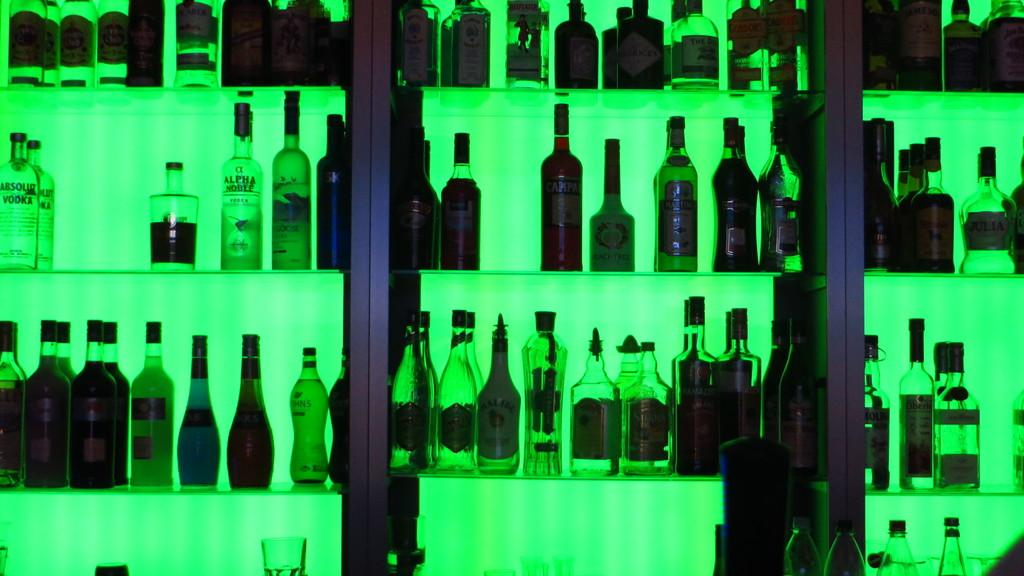What objects are present in the image? There are bottles in the image. Where are the bottles located? The bottles are on a rack. What type of test can be seen being conducted on the snails in the image? There are no snails or tests present in the image; it only features bottles on a rack. 